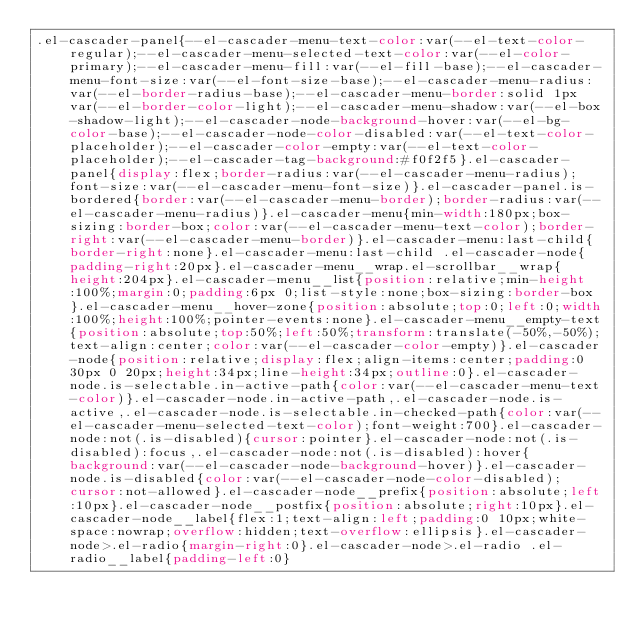Convert code to text. <code><loc_0><loc_0><loc_500><loc_500><_CSS_>.el-cascader-panel{--el-cascader-menu-text-color:var(--el-text-color-regular);--el-cascader-menu-selected-text-color:var(--el-color-primary);--el-cascader-menu-fill:var(--el-fill-base);--el-cascader-menu-font-size:var(--el-font-size-base);--el-cascader-menu-radius:var(--el-border-radius-base);--el-cascader-menu-border:solid 1px var(--el-border-color-light);--el-cascader-menu-shadow:var(--el-box-shadow-light);--el-cascader-node-background-hover:var(--el-bg-color-base);--el-cascader-node-color-disabled:var(--el-text-color-placeholder);--el-cascader-color-empty:var(--el-text-color-placeholder);--el-cascader-tag-background:#f0f2f5}.el-cascader-panel{display:flex;border-radius:var(--el-cascader-menu-radius);font-size:var(--el-cascader-menu-font-size)}.el-cascader-panel.is-bordered{border:var(--el-cascader-menu-border);border-radius:var(--el-cascader-menu-radius)}.el-cascader-menu{min-width:180px;box-sizing:border-box;color:var(--el-cascader-menu-text-color);border-right:var(--el-cascader-menu-border)}.el-cascader-menu:last-child{border-right:none}.el-cascader-menu:last-child .el-cascader-node{padding-right:20px}.el-cascader-menu__wrap.el-scrollbar__wrap{height:204px}.el-cascader-menu__list{position:relative;min-height:100%;margin:0;padding:6px 0;list-style:none;box-sizing:border-box}.el-cascader-menu__hover-zone{position:absolute;top:0;left:0;width:100%;height:100%;pointer-events:none}.el-cascader-menu__empty-text{position:absolute;top:50%;left:50%;transform:translate(-50%,-50%);text-align:center;color:var(--el-cascader-color-empty)}.el-cascader-node{position:relative;display:flex;align-items:center;padding:0 30px 0 20px;height:34px;line-height:34px;outline:0}.el-cascader-node.is-selectable.in-active-path{color:var(--el-cascader-menu-text-color)}.el-cascader-node.in-active-path,.el-cascader-node.is-active,.el-cascader-node.is-selectable.in-checked-path{color:var(--el-cascader-menu-selected-text-color);font-weight:700}.el-cascader-node:not(.is-disabled){cursor:pointer}.el-cascader-node:not(.is-disabled):focus,.el-cascader-node:not(.is-disabled):hover{background:var(--el-cascader-node-background-hover)}.el-cascader-node.is-disabled{color:var(--el-cascader-node-color-disabled);cursor:not-allowed}.el-cascader-node__prefix{position:absolute;left:10px}.el-cascader-node__postfix{position:absolute;right:10px}.el-cascader-node__label{flex:1;text-align:left;padding:0 10px;white-space:nowrap;overflow:hidden;text-overflow:ellipsis}.el-cascader-node>.el-radio{margin-right:0}.el-cascader-node>.el-radio .el-radio__label{padding-left:0}</code> 